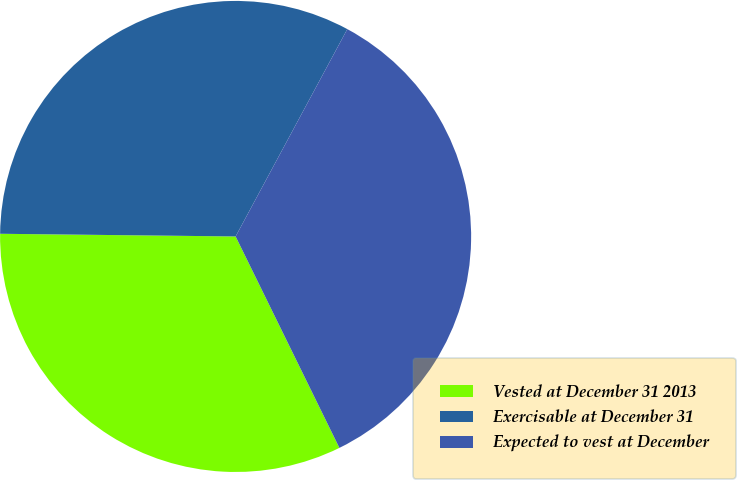<chart> <loc_0><loc_0><loc_500><loc_500><pie_chart><fcel>Vested at December 31 2013<fcel>Exercisable at December 31<fcel>Expected to vest at December<nl><fcel>32.44%<fcel>32.68%<fcel>34.87%<nl></chart> 